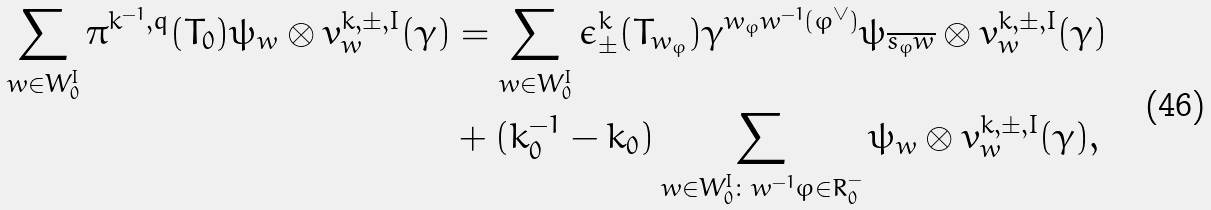Convert formula to latex. <formula><loc_0><loc_0><loc_500><loc_500>\sum _ { w \in W _ { 0 } ^ { I } } \pi ^ { k ^ { - 1 } , q } ( T _ { 0 } ) \psi _ { w } \otimes v _ { w } ^ { k , \pm , I } ( \gamma ) & = \sum _ { w \in W _ { 0 } ^ { I } } \epsilon _ { \pm } ^ { k } ( T _ { w _ { \varphi } } ) \gamma ^ { w _ { \varphi } w ^ { - 1 } ( \varphi ^ { \vee } ) } \psi _ { \overline { s _ { \varphi } w } } \otimes v _ { w } ^ { k , \pm , I } ( \gamma ) \\ & + ( k _ { 0 } ^ { - 1 } - k _ { 0 } ) \sum _ { w \in W _ { 0 } ^ { I } \colon w ^ { - 1 } \varphi \in R _ { 0 } ^ { - } } \psi _ { w } \otimes v _ { w } ^ { k , \pm , I } ( \gamma ) ,</formula> 